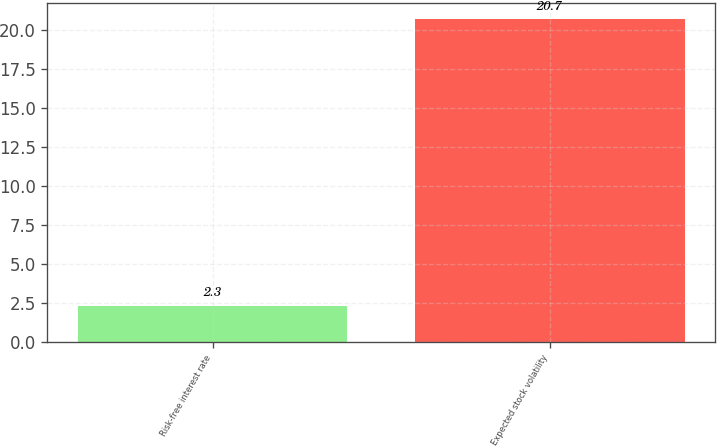Convert chart to OTSL. <chart><loc_0><loc_0><loc_500><loc_500><bar_chart><fcel>Risk-free interest rate<fcel>Expected stock volatility<nl><fcel>2.3<fcel>20.7<nl></chart> 